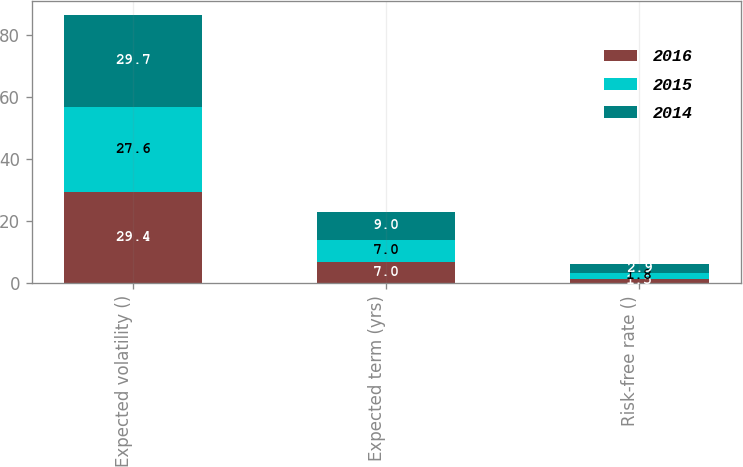Convert chart. <chart><loc_0><loc_0><loc_500><loc_500><stacked_bar_chart><ecel><fcel>Expected volatility ()<fcel>Expected term (yrs)<fcel>Risk-free rate ()<nl><fcel>2016<fcel>29.4<fcel>7<fcel>1.5<nl><fcel>2015<fcel>27.6<fcel>7<fcel>1.8<nl><fcel>2014<fcel>29.7<fcel>9<fcel>2.9<nl></chart> 